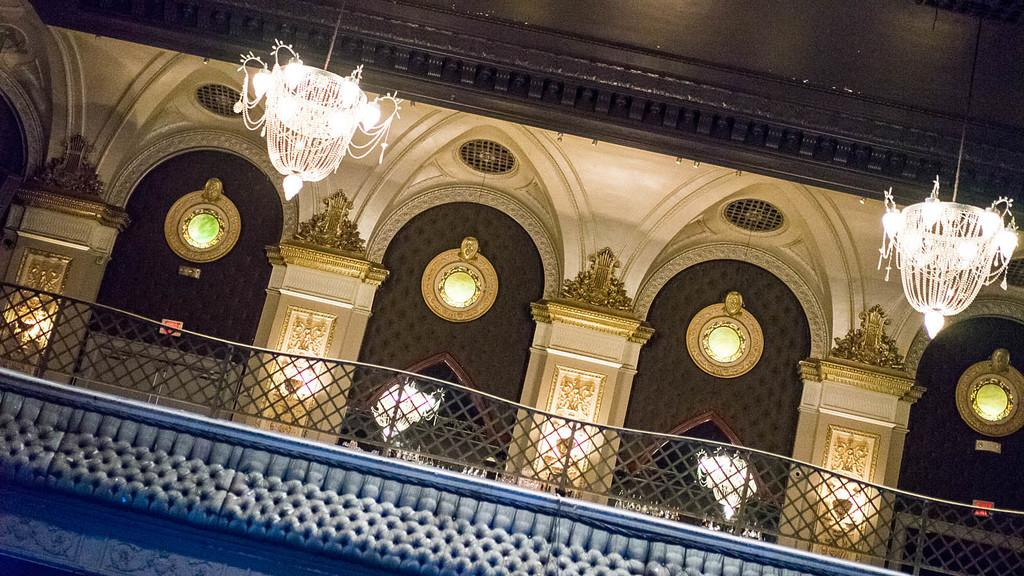What is the main structure in the image? There is a building in the middle of the image. What type of lighting fixtures are present at the top of the building? There are two chandeliers at the top of the building. What material is used for the railing at the bottom of the building? There is a wooden railing at the bottom of the building. Is there a river flowing through the downtown area in the image? There is no mention of a river or downtown area in the image; it only features a building with chandeliers and a wooden railing. 